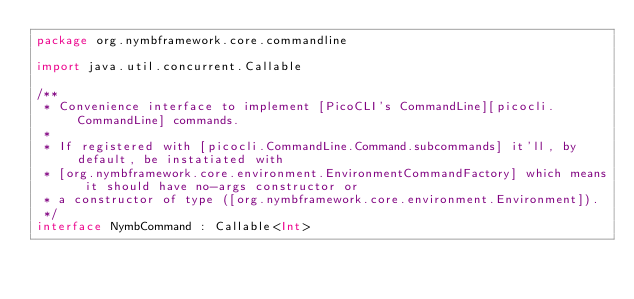<code> <loc_0><loc_0><loc_500><loc_500><_Kotlin_>package org.nymbframework.core.commandline

import java.util.concurrent.Callable

/**
 * Convenience interface to implement [PicoCLI's CommandLine][picocli.CommandLine] commands.
 *
 * If registered with [picocli.CommandLine.Command.subcommands] it'll, by default, be instatiated with
 * [org.nymbframework.core.environment.EnvironmentCommandFactory] which means it should have no-args constructor or
 * a constructor of type ([org.nymbframework.core.environment.Environment]).
 */
interface NymbCommand : Callable<Int>
</code> 